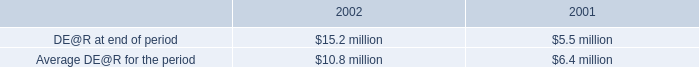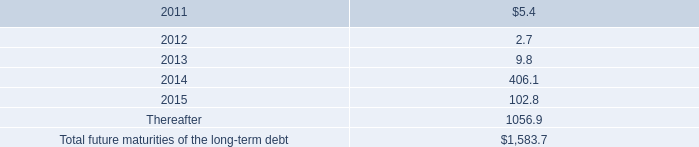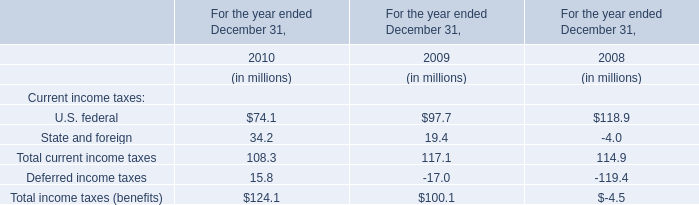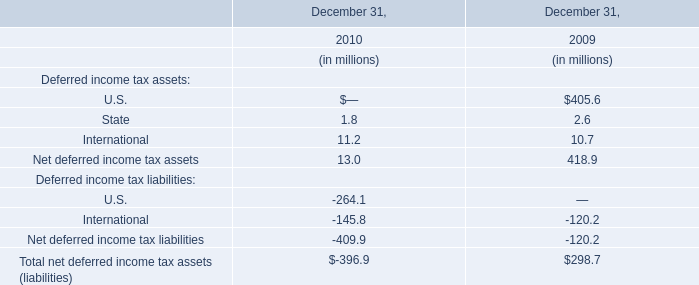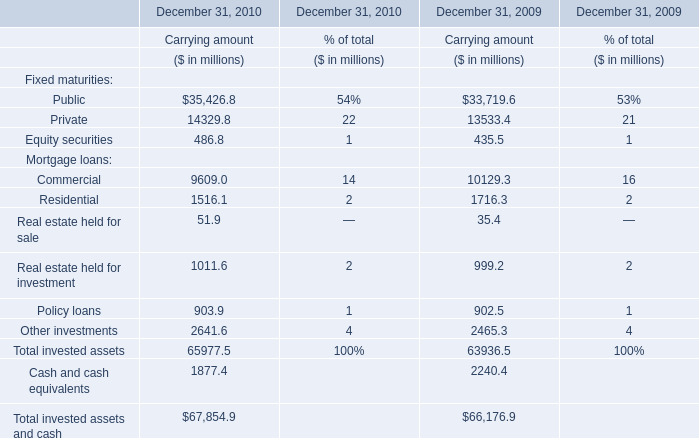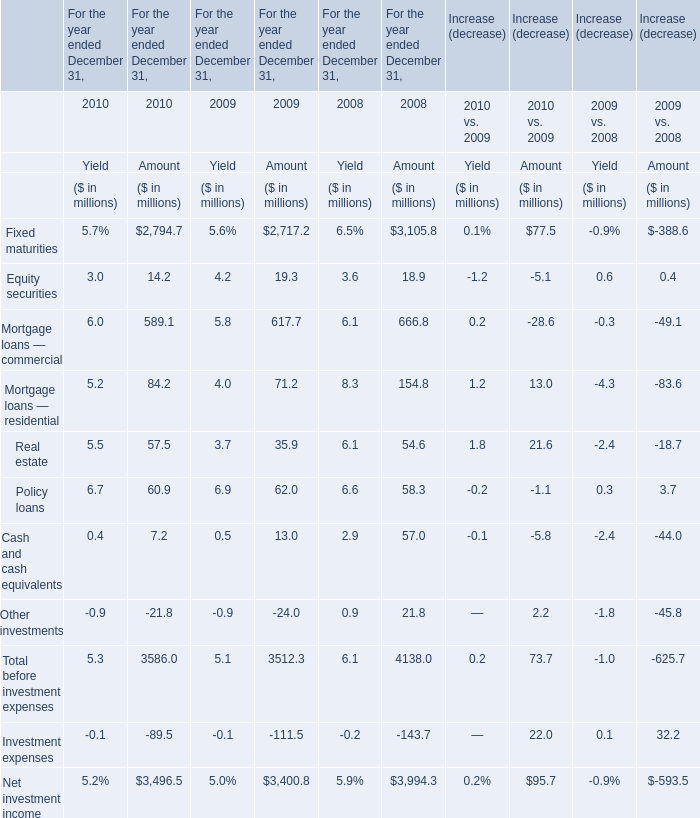How many kinds of Fixed maturities in 2010 are greater than those in the previous year? 
Answer: 3 (Public,Private and Equity securities). 